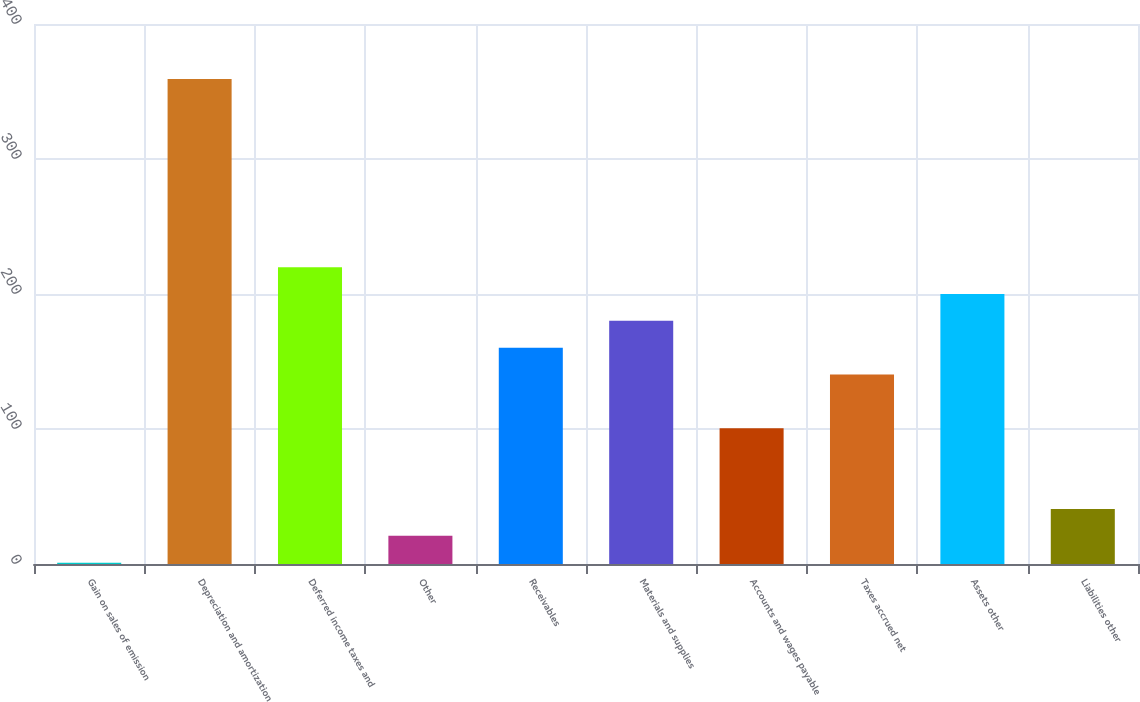<chart> <loc_0><loc_0><loc_500><loc_500><bar_chart><fcel>Gain on sales of emission<fcel>Depreciation and amortization<fcel>Deferred income taxes and<fcel>Other<fcel>Receivables<fcel>Materials and supplies<fcel>Accounts and wages payable<fcel>Taxes accrued net<fcel>Assets other<fcel>Liabilities other<nl><fcel>1<fcel>359.2<fcel>219.9<fcel>20.9<fcel>160.2<fcel>180.1<fcel>100.5<fcel>140.3<fcel>200<fcel>40.8<nl></chart> 